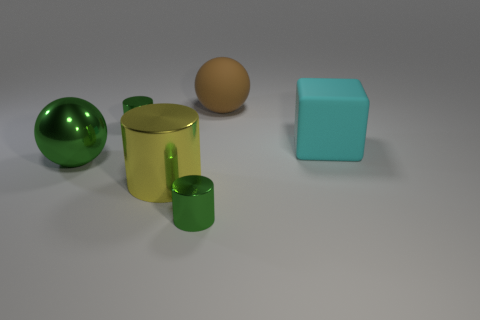Are there the same number of large green balls that are behind the large cyan matte cube and large red cylinders?
Provide a succinct answer. Yes. What number of tiny green things have the same shape as the large yellow shiny thing?
Your answer should be very brief. 2. There is a brown matte object that is on the left side of the thing that is right of the big ball on the right side of the green metal ball; how big is it?
Offer a very short reply. Large. Is the material of the large green ball on the left side of the big metal cylinder the same as the yellow thing?
Ensure brevity in your answer.  Yes. Is the number of big objects in front of the large yellow cylinder the same as the number of large yellow metallic things left of the cyan block?
Provide a short and direct response. No. There is a brown thing that is the same shape as the large green thing; what material is it?
Provide a short and direct response. Rubber. Is there a sphere that is to the left of the green metal cylinder that is left of the tiny thing that is in front of the large cylinder?
Make the answer very short. Yes. There is a small object to the right of the big cylinder; is it the same shape as the green thing that is behind the green shiny ball?
Provide a succinct answer. Yes. Is the number of tiny green objects that are on the left side of the large cube greater than the number of small purple shiny things?
Your answer should be compact. Yes. How many things are either cylinders or large yellow objects?
Your answer should be very brief. 3. 